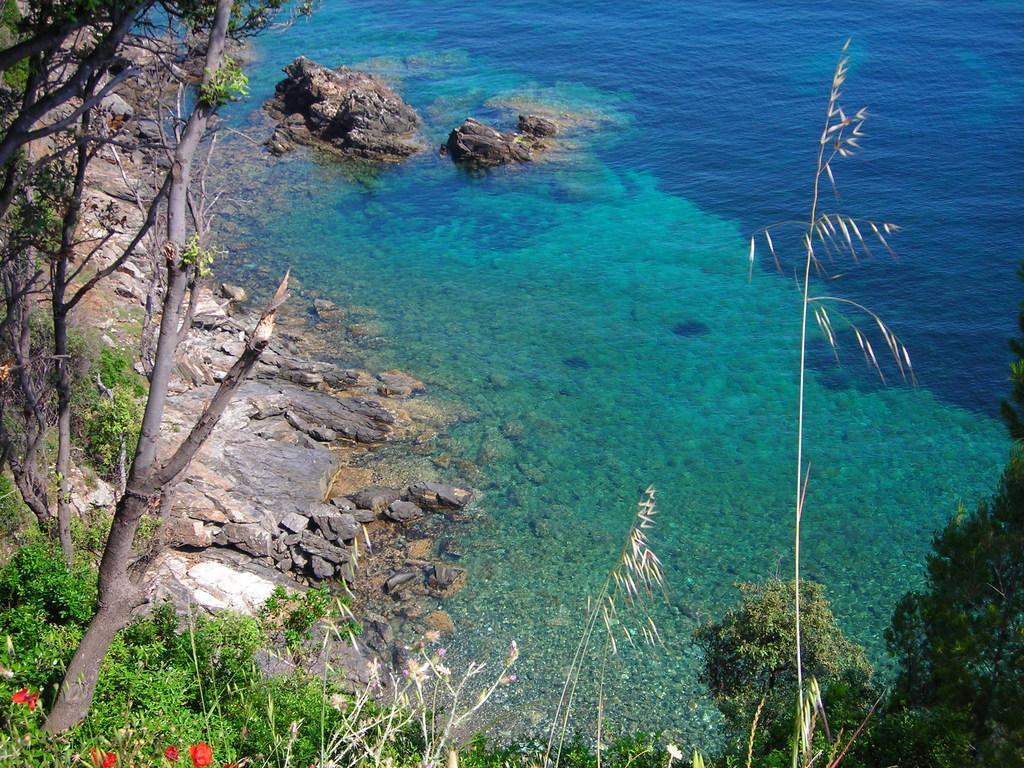Can you describe this image briefly? On the left side of the image we can see trees. At the bottom there are flowers. In the background there is water and we can see stones. 